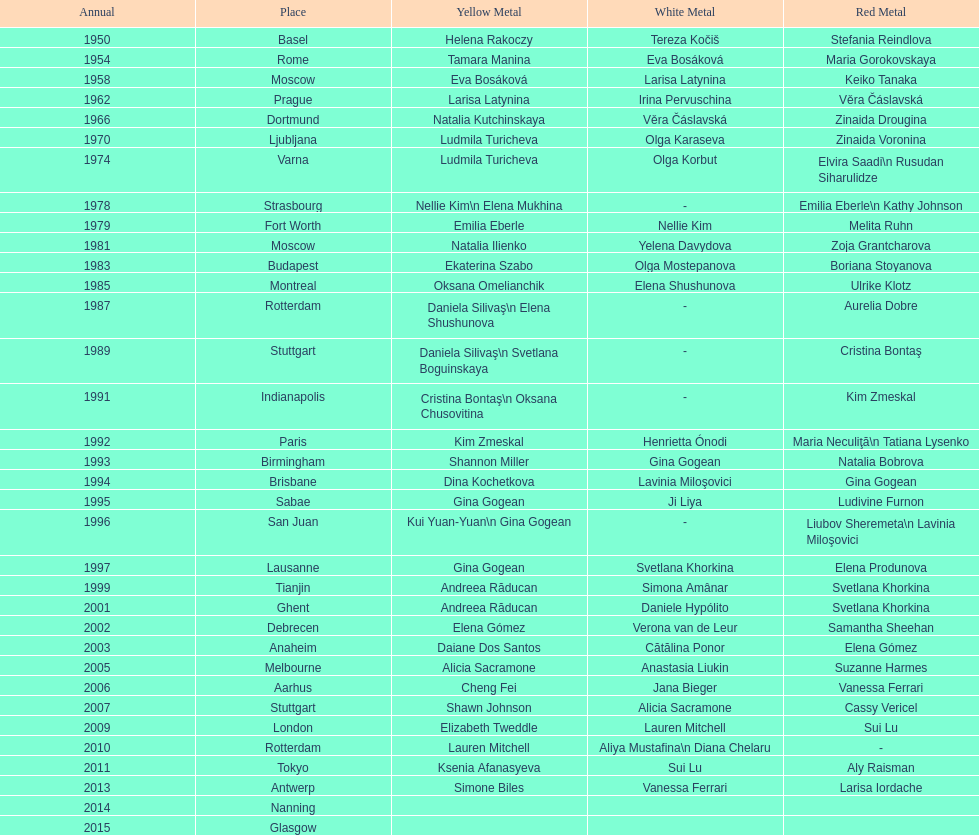What is the total number of russian gymnasts that have won silver. 8. 